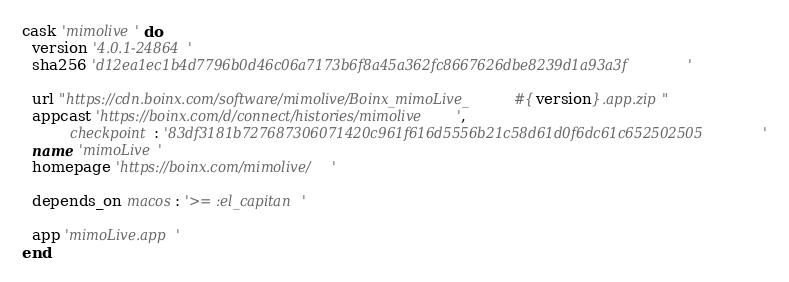<code> <loc_0><loc_0><loc_500><loc_500><_Ruby_>cask 'mimolive' do
  version '4.0.1-24864'
  sha256 'd12ea1ec1b4d7796b0d46c06a7173b6f8a45a362fc8667626dbe8239d1a93a3f'

  url "https://cdn.boinx.com/software/mimolive/Boinx_mimoLive_#{version}.app.zip"
  appcast 'https://boinx.com/d/connect/histories/mimolive',
          checkpoint: '83df3181b727687306071420c961f616d5556b21c58d61d0f6dc61c652502505'
  name 'mimoLive'
  homepage 'https://boinx.com/mimolive/'

  depends_on macos: '>= :el_capitan'

  app 'mimoLive.app'
end
</code> 